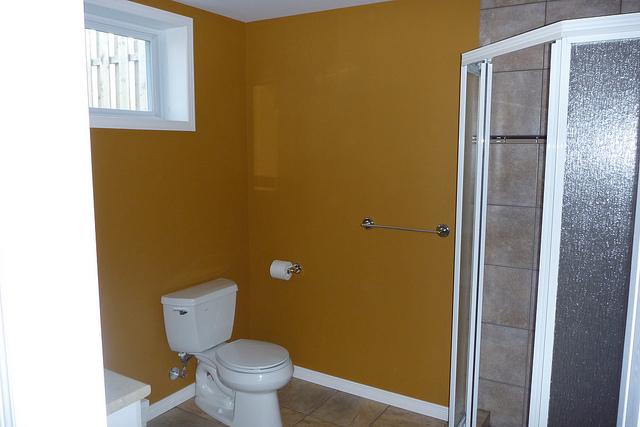How many towel racks are in the room?
Short answer required. 1. What color is the wall?
Keep it brief. Yellow. What color is on the wall?
Be succinct. Yellow. Where can tiles be seen?
Concise answer only. Floor. What is covering the wall?
Answer briefly. Paint. 